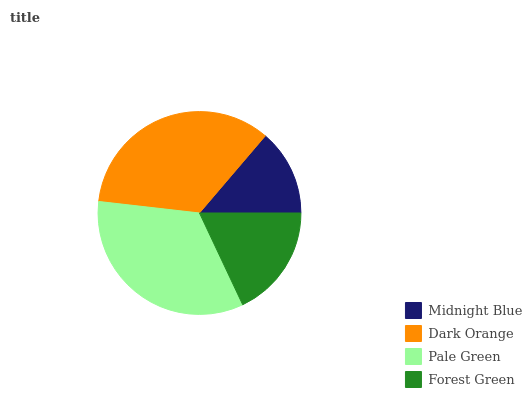Is Midnight Blue the minimum?
Answer yes or no. Yes. Is Dark Orange the maximum?
Answer yes or no. Yes. Is Pale Green the minimum?
Answer yes or no. No. Is Pale Green the maximum?
Answer yes or no. No. Is Dark Orange greater than Pale Green?
Answer yes or no. Yes. Is Pale Green less than Dark Orange?
Answer yes or no. Yes. Is Pale Green greater than Dark Orange?
Answer yes or no. No. Is Dark Orange less than Pale Green?
Answer yes or no. No. Is Pale Green the high median?
Answer yes or no. Yes. Is Forest Green the low median?
Answer yes or no. Yes. Is Dark Orange the high median?
Answer yes or no. No. Is Dark Orange the low median?
Answer yes or no. No. 